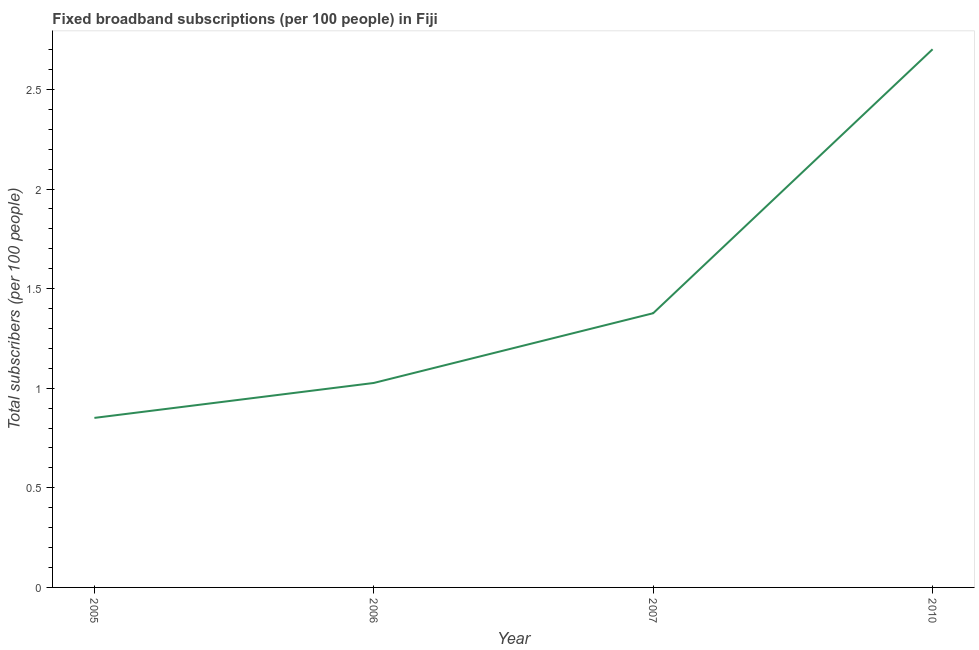What is the total number of fixed broadband subscriptions in 2005?
Provide a short and direct response. 0.85. Across all years, what is the maximum total number of fixed broadband subscriptions?
Offer a terse response. 2.7. Across all years, what is the minimum total number of fixed broadband subscriptions?
Your answer should be compact. 0.85. In which year was the total number of fixed broadband subscriptions minimum?
Offer a very short reply. 2005. What is the sum of the total number of fixed broadband subscriptions?
Provide a short and direct response. 5.96. What is the difference between the total number of fixed broadband subscriptions in 2005 and 2007?
Make the answer very short. -0.53. What is the average total number of fixed broadband subscriptions per year?
Your answer should be compact. 1.49. What is the median total number of fixed broadband subscriptions?
Ensure brevity in your answer.  1.2. Do a majority of the years between 2006 and 2007 (inclusive) have total number of fixed broadband subscriptions greater than 0.9 ?
Keep it short and to the point. Yes. What is the ratio of the total number of fixed broadband subscriptions in 2006 to that in 2010?
Provide a succinct answer. 0.38. Is the total number of fixed broadband subscriptions in 2005 less than that in 2006?
Your response must be concise. Yes. Is the difference between the total number of fixed broadband subscriptions in 2005 and 2010 greater than the difference between any two years?
Your answer should be very brief. Yes. What is the difference between the highest and the second highest total number of fixed broadband subscriptions?
Provide a succinct answer. 1.33. What is the difference between the highest and the lowest total number of fixed broadband subscriptions?
Your answer should be very brief. 1.85. Does the total number of fixed broadband subscriptions monotonically increase over the years?
Offer a very short reply. Yes. Are the values on the major ticks of Y-axis written in scientific E-notation?
Your answer should be very brief. No. What is the title of the graph?
Provide a short and direct response. Fixed broadband subscriptions (per 100 people) in Fiji. What is the label or title of the X-axis?
Offer a very short reply. Year. What is the label or title of the Y-axis?
Offer a very short reply. Total subscribers (per 100 people). What is the Total subscribers (per 100 people) in 2005?
Your answer should be very brief. 0.85. What is the Total subscribers (per 100 people) in 2006?
Your answer should be compact. 1.03. What is the Total subscribers (per 100 people) in 2007?
Make the answer very short. 1.38. What is the Total subscribers (per 100 people) in 2010?
Provide a short and direct response. 2.7. What is the difference between the Total subscribers (per 100 people) in 2005 and 2006?
Your answer should be very brief. -0.18. What is the difference between the Total subscribers (per 100 people) in 2005 and 2007?
Your answer should be very brief. -0.53. What is the difference between the Total subscribers (per 100 people) in 2005 and 2010?
Your response must be concise. -1.85. What is the difference between the Total subscribers (per 100 people) in 2006 and 2007?
Offer a terse response. -0.35. What is the difference between the Total subscribers (per 100 people) in 2006 and 2010?
Give a very brief answer. -1.68. What is the difference between the Total subscribers (per 100 people) in 2007 and 2010?
Your response must be concise. -1.33. What is the ratio of the Total subscribers (per 100 people) in 2005 to that in 2006?
Ensure brevity in your answer.  0.83. What is the ratio of the Total subscribers (per 100 people) in 2005 to that in 2007?
Your answer should be compact. 0.62. What is the ratio of the Total subscribers (per 100 people) in 2005 to that in 2010?
Keep it short and to the point. 0.32. What is the ratio of the Total subscribers (per 100 people) in 2006 to that in 2007?
Your response must be concise. 0.75. What is the ratio of the Total subscribers (per 100 people) in 2006 to that in 2010?
Keep it short and to the point. 0.38. What is the ratio of the Total subscribers (per 100 people) in 2007 to that in 2010?
Keep it short and to the point. 0.51. 